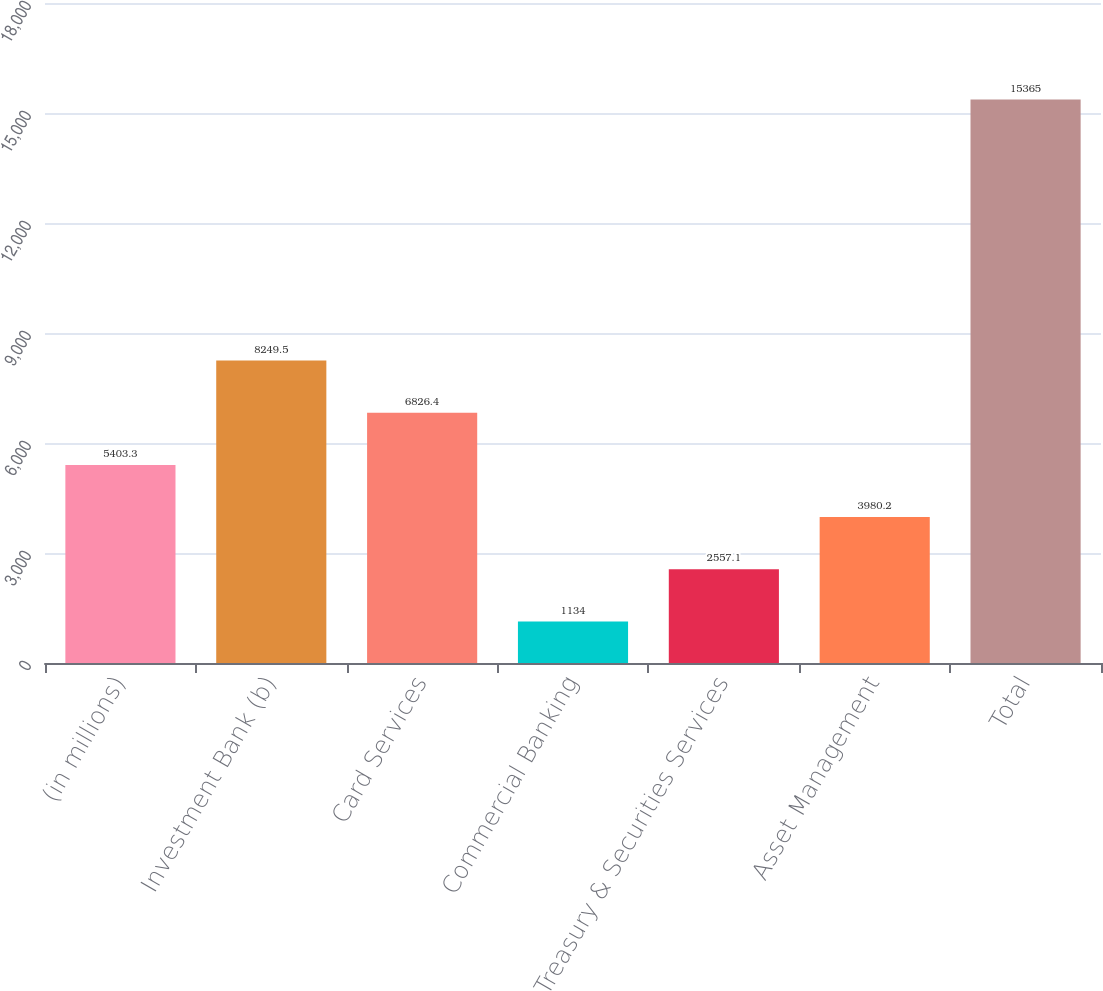Convert chart. <chart><loc_0><loc_0><loc_500><loc_500><bar_chart><fcel>(in millions)<fcel>Investment Bank (b)<fcel>Card Services<fcel>Commercial Banking<fcel>Treasury & Securities Services<fcel>Asset Management<fcel>Total<nl><fcel>5403.3<fcel>8249.5<fcel>6826.4<fcel>1134<fcel>2557.1<fcel>3980.2<fcel>15365<nl></chart> 